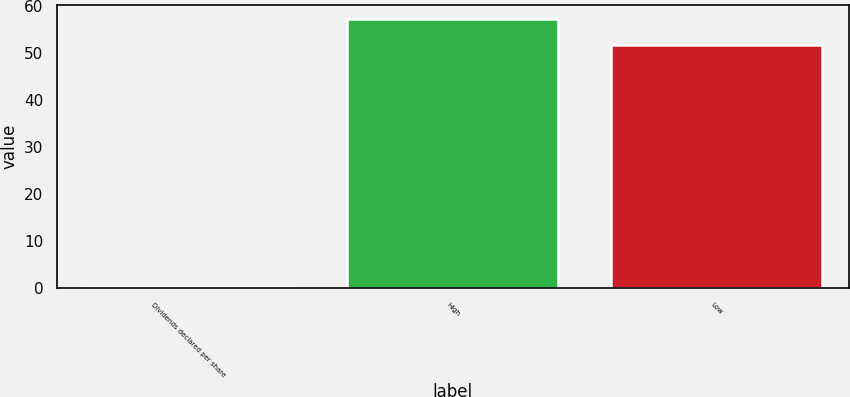Convert chart. <chart><loc_0><loc_0><loc_500><loc_500><bar_chart><fcel>Dividends declared per share<fcel>High<fcel>Low<nl><fcel>0.27<fcel>57.25<fcel>51.6<nl></chart> 